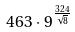<formula> <loc_0><loc_0><loc_500><loc_500>4 6 3 \cdot 9 ^ { \frac { 3 2 4 } { \sqrt { 8 } } }</formula> 